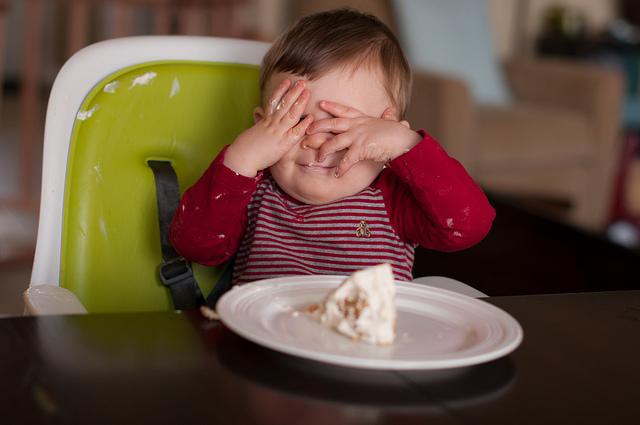What is the baby doing?
Be succinct. Eating. What color is the plate?
Be succinct. White. What color is the middle part of the baby seat?
Quick response, please. Green. What is the baby holding?
Give a very brief answer. Face. What is the baby eating?
Keep it brief. Cake. 